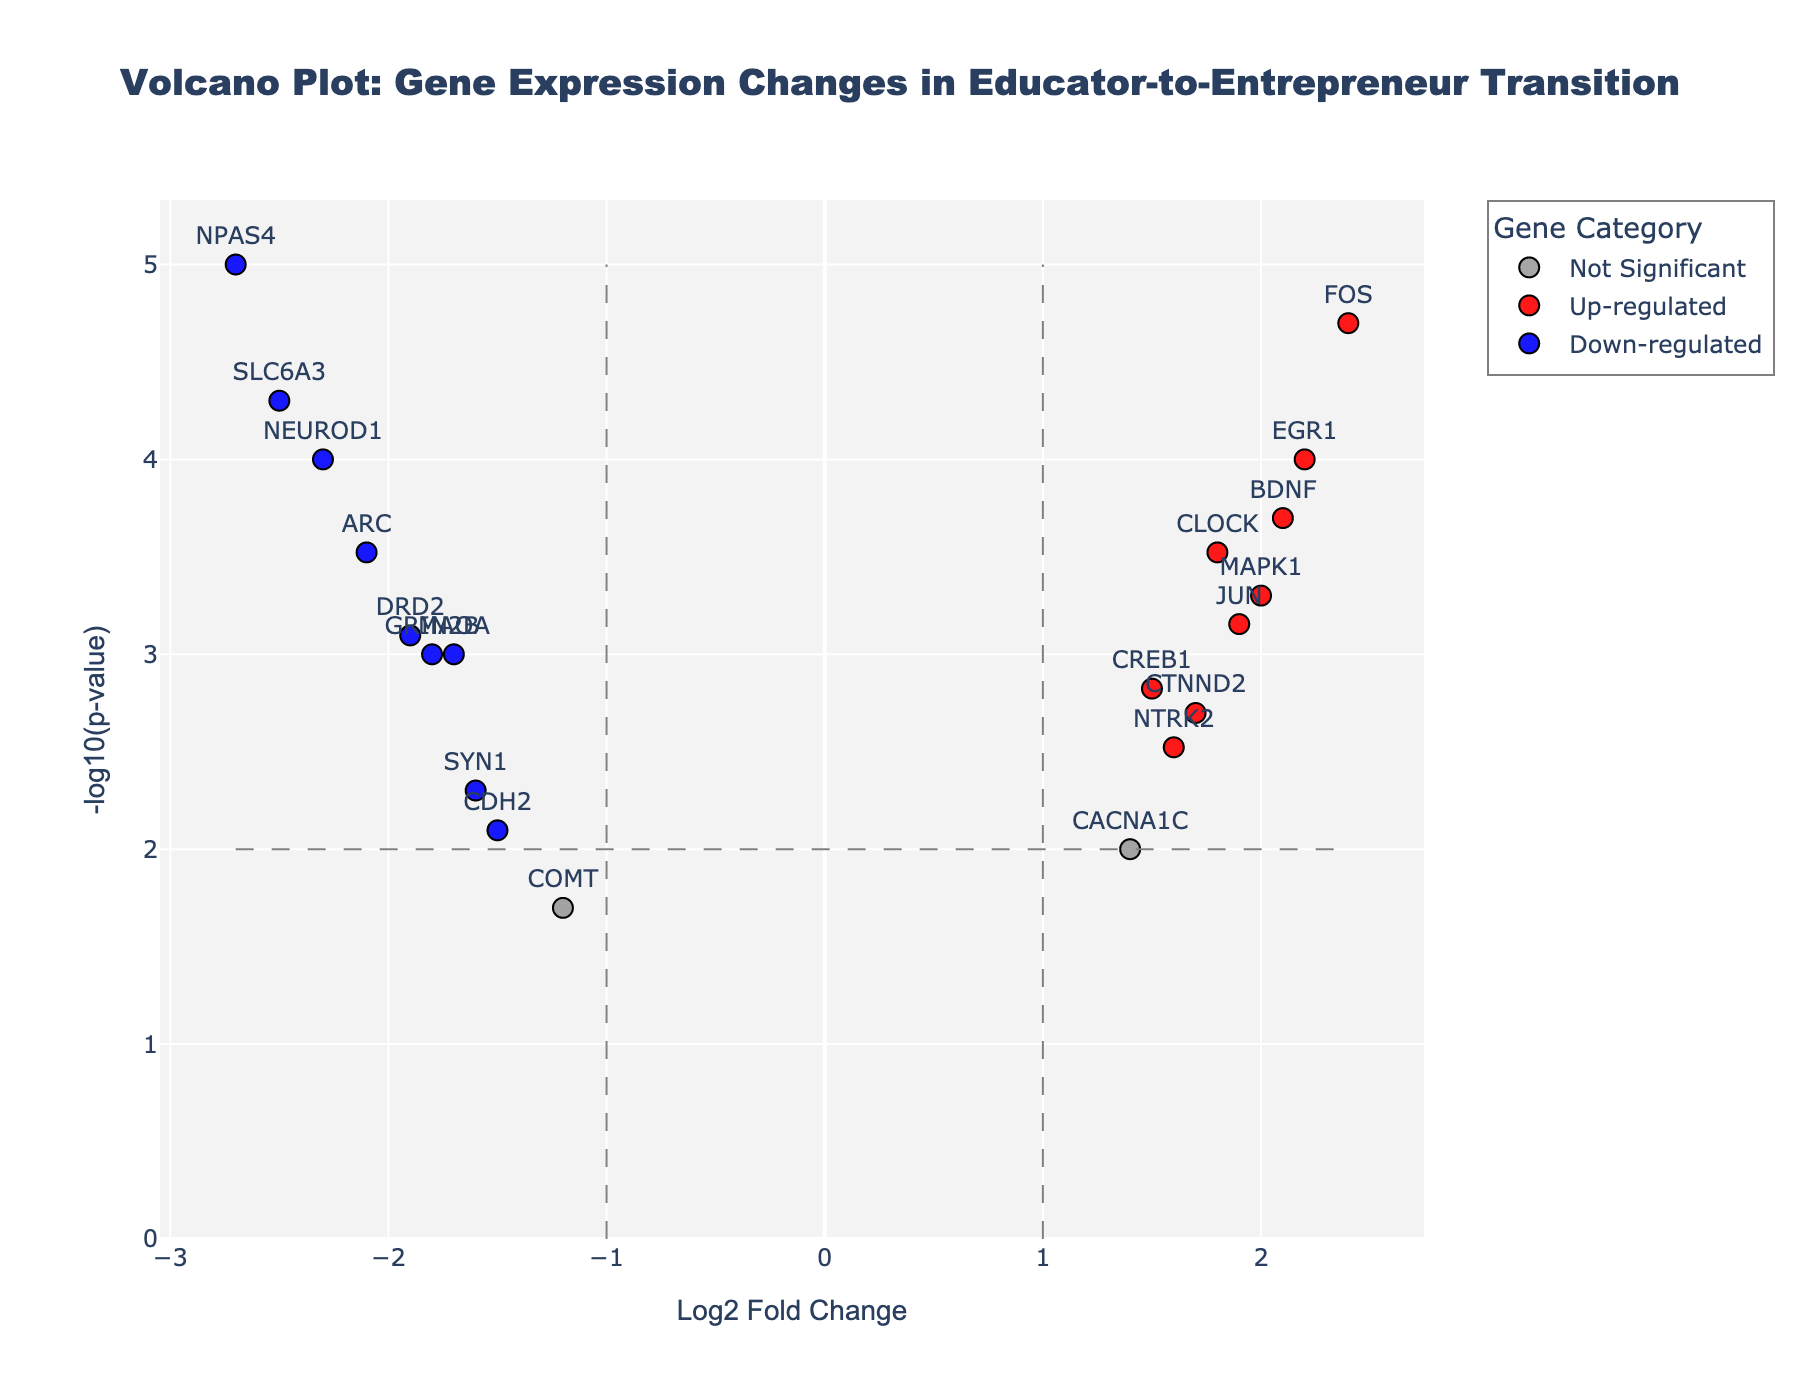What is the title of the figure? The title is usually written at the top of the figure. In this case, the title reads "Volcano Plot: Gene Expression Changes in Educator-to-Entrepreneur Transition."
Answer: Volcano Plot: Gene Expression Changes in Educator-to-Entrepreneur Transition Which category of genes has the most data points? By looking at the legend and the scatter points, it appears that the "Not Significant" category has the most data points. These points are colored in grey.
Answer: Not Significant How many genes are down-regulated and significant? Down-regulated and significant genes are represented by blue dots. By counting the blue dots on the plot, we can determine there are 5 such genes: NEUROD1, DRD2, SLC6A3, NPAS4, and ARC.
Answer: 5 Which gene has the highest -log10(p-value)? The gene with the highest -log10(p-value) will be the one appearing at the highest vertical position in the plot. This gene is NPAS4.
Answer: NPAS4 What is the Log2 Fold Change of the gene CREB1? Find the corresponding point for CREB1 on the plot. The Log2 Fold Change is represented on the x-axis. It is 1.5 for CREB1.
Answer: 1.5 Which gene has the lowest Log2 Fold Change? To find the gene with the lowest Log2 Fold Change, look for the point farthest left on the x-axis. This gene is NPAS4 with a Log2 Fold Change of -2.7.
Answer: NPAS4 How many genes are up-regulated and significant? Up-regulated and significant genes are represented by red dots. By counting these dots on the plot, we can see there are 6 such genes: CLOCK, BDNF, FOS, JUN, EGR1, and MAPK1.
Answer: 6 Which gene has the highest Log2 Fold Change? The gene with the highest Log2 Fold Change will be the point farthest right on the x-axis. This gene is FOS with a Log2 Fold Change of 2.4.
Answer: FOS How many genes have a p-value less than 0.001? To find the genes with a p-value less than 0.001, look for points with a -log10(p-value) higher than 3. Count these points. There are 10 genes meeting this criterion.
Answer: 10 Which genes are categorized as significant but not up- or down-regulated? These genes would fall into the "Significant" category colored in orange but not in red or blue. There are no such points upon inspection of the plot.
Answer: None 